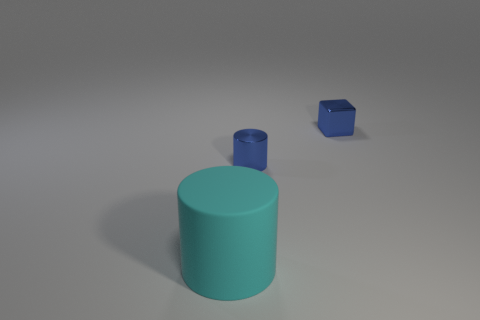Add 1 brown shiny objects. How many objects exist? 4 Subtract all cylinders. How many objects are left? 1 Add 3 small metal cylinders. How many small metal cylinders exist? 4 Subtract 0 yellow cylinders. How many objects are left? 3 Subtract all tiny blue rubber cylinders. Subtract all big rubber things. How many objects are left? 2 Add 3 tiny blue cylinders. How many tiny blue cylinders are left? 4 